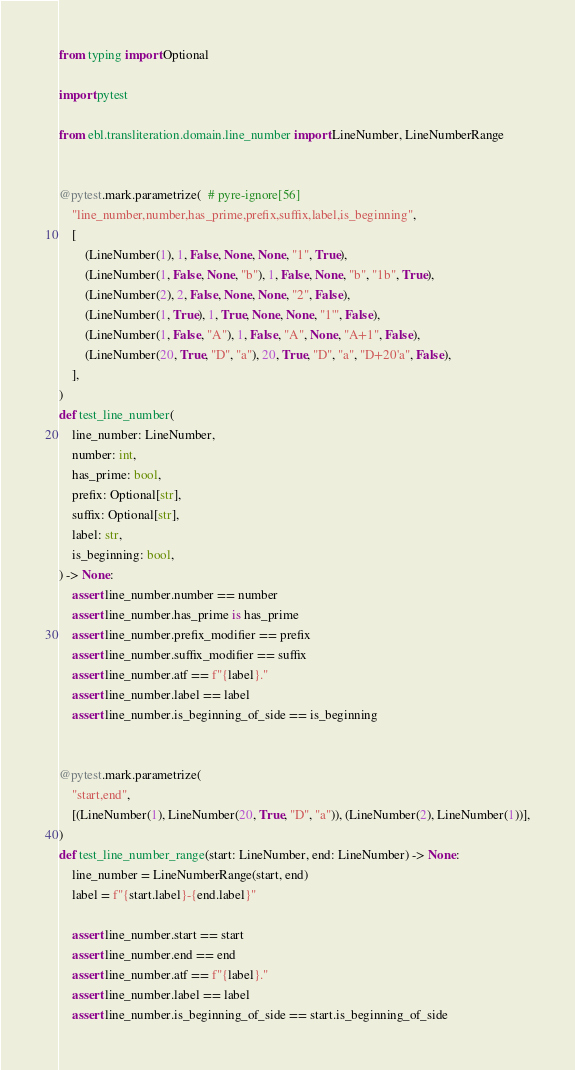<code> <loc_0><loc_0><loc_500><loc_500><_Python_>from typing import Optional

import pytest

from ebl.transliteration.domain.line_number import LineNumber, LineNumberRange


@pytest.mark.parametrize(  # pyre-ignore[56]
    "line_number,number,has_prime,prefix,suffix,label,is_beginning",
    [
        (LineNumber(1), 1, False, None, None, "1", True),
        (LineNumber(1, False, None, "b"), 1, False, None, "b", "1b", True),
        (LineNumber(2), 2, False, None, None, "2", False),
        (LineNumber(1, True), 1, True, None, None, "1'", False),
        (LineNumber(1, False, "A"), 1, False, "A", None, "A+1", False),
        (LineNumber(20, True, "D", "a"), 20, True, "D", "a", "D+20'a", False),
    ],
)
def test_line_number(
    line_number: LineNumber,
    number: int,
    has_prime: bool,
    prefix: Optional[str],
    suffix: Optional[str],
    label: str,
    is_beginning: bool,
) -> None:
    assert line_number.number == number
    assert line_number.has_prime is has_prime
    assert line_number.prefix_modifier == prefix
    assert line_number.suffix_modifier == suffix
    assert line_number.atf == f"{label}."
    assert line_number.label == label
    assert line_number.is_beginning_of_side == is_beginning


@pytest.mark.parametrize(
    "start,end",
    [(LineNumber(1), LineNumber(20, True, "D", "a")), (LineNumber(2), LineNumber(1))],
)
def test_line_number_range(start: LineNumber, end: LineNumber) -> None:
    line_number = LineNumberRange(start, end)
    label = f"{start.label}-{end.label}"

    assert line_number.start == start
    assert line_number.end == end
    assert line_number.atf == f"{label}."
    assert line_number.label == label
    assert line_number.is_beginning_of_side == start.is_beginning_of_side
</code> 